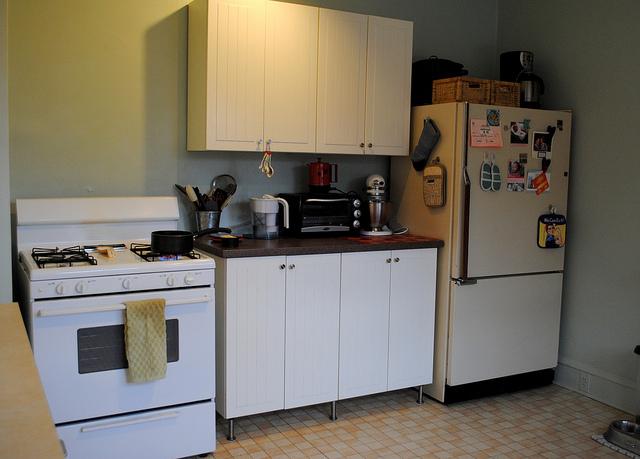Does this home belong to a single person or a family?
Answer briefly. Family. What is the tan colored thing on the right?
Concise answer only. Refrigerator. How many burners does the stove have?
Answer briefly. 4. What is the item on the stove for?
Be succinct. Cooking. What is sitting on top of the stove?
Give a very brief answer. Pot. Is that an electric oven?
Answer briefly. No. What room of the house is this?
Keep it brief. Kitchen. What color are the towels hanging on the dishwasher?
Give a very brief answer. Yellow. Is the stove gas or electric?
Concise answer only. Gas. Does the fridge have an ice maker?
Answer briefly. No. How many towels are there?
Give a very brief answer. 1. What color is the oven door?
Write a very short answer. White. Do the appliances appear to be new?
Concise answer only. No. What is on the stove?
Quick response, please. Pot. Is the kitchen new?
Be succinct. No. How many refrigerators are there?
Be succinct. 1. How many gas stoves are in the room?
Be succinct. 1. Is that a microwave or a toaster?
Answer briefly. Toaster. What beverage is on top of the refrigerator?
Short answer required. Coffee. How many floor tiles are visible?
Short answer required. Dozens. Is the freezer on top in this refrigerator?
Be succinct. No. What pattern is on the oven mitt?
Short answer required. None. Does the home have a pet?
Write a very short answer. Yes. Is their a dishwasher in this kitchen?
Give a very brief answer. No. What type of energy source does the stove use?
Keep it brief. Gas. Who took this picture?
Be succinct. Owner. What kind of fridge is in this picture?
Keep it brief. Bottom freezer. Is there a stove?
Be succinct. Yes. How many items are placed on the front of the refrigerator?
Quick response, please. 7. What is on the counter next to the toaster?
Concise answer only. Blender. Are these appliances cutting edge?
Short answer required. No. What small kitchen appliance is on top of the refrigerator?
Keep it brief. Coffee maker. 